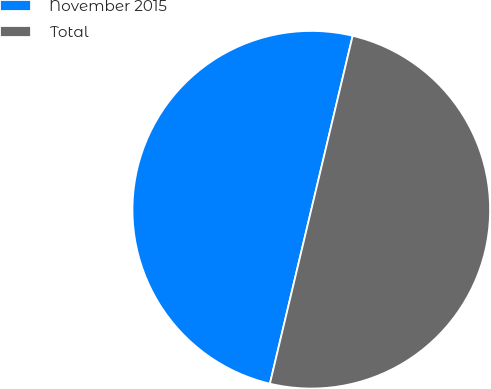<chart> <loc_0><loc_0><loc_500><loc_500><pie_chart><fcel>November 2015<fcel>Total<nl><fcel>50.0%<fcel>50.0%<nl></chart> 